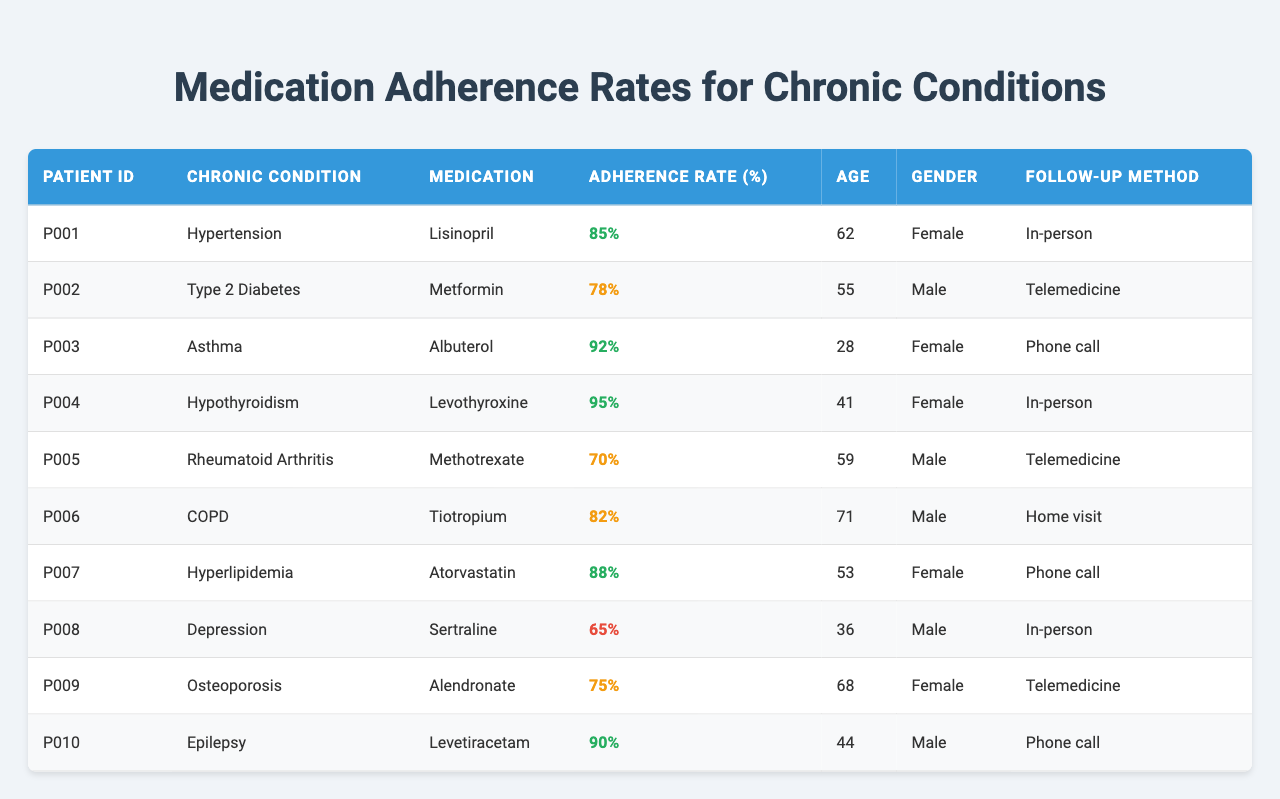What is the adherence rate for the medication prescribed to Patient P001? According to the table, the adherence rate for Patient P001, who is prescribed Lisinopril for hypertension, is 85%.
Answer: 85% Which patient has the highest medication adherence rate and what is their condition? The table shows that Patient P004 has the highest medication adherence rate of 95%, and their condition is hypothyroidism.
Answer: Patient P004; Hypothyroidism How many patients have an adherence rate below 70%? By reviewing the table, it can be seen that there are two patients with adherence rates below 70%: Patient P005 (70%) and Patient P008 (65%). Hence, the count is 1.
Answer: 1 What is the average adherence rate for all patients listed? The adherence rates are 85, 78, 92, 95, 70, 82, 88, 65, 75, and 90. Adding these (85 + 78 + 92 + 95 + 70 + 82 + 88 + 65 + 75 + 90 =  830) and dividing by the number of patients (10) gives an average adherence rate of 83%.
Answer: 83% Are there more female or male patients in the table? Counting the gender in the rows, there are 5 female patients (P001, P003, P004, P007, P009) and 5 male patients (P002, P005, P006, P008, P010). Therefore, the number of male and female patients is equal, resulting in a "No".
Answer: No What percentage of patients were followed up through telemedicine? In the table, there are 10 patients in total. Among them, 3 patients (P002, P005, P009) were followed through telemedicine, which is 3/10 = 30%.
Answer: 30% What is the age of the patient who has the second lowest medication adherence rate? The second lowest adherence rate is 70% for Patient P005, who is 59 years old.
Answer: 59 If we combine the adherence rates for patients over 60 years old, what is the total? Looking at the patients over 60 (P006 and P009), their adherence rates are 82% and 75%, respectively. Adding these gives 82 + 75 = 157%.
Answer: 157% Is there any patient who has an adherence rate of exactly 70%? Based on the table, Patient P005 has an adherence rate of 70%. This confirms that at least one patient does have an adherence rate of exactly 70%.
Answer: Yes How does the adherence rate of males compare to that of females? Adding the adherence rates for males (78 + 70 + 82 + 65 + 90 = 385) results in an average of 77%. The adherence rates for females (85 + 92 + 95 + 88 + 75 = 435) results in an average of 87%. Since 87% is higher than 77%, females have a higher adherence rate.
Answer: Females have a higher adherence rate 